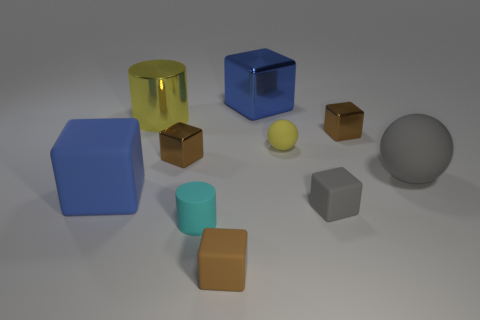Subtract all brown cubes. How many were subtracted if there are1brown cubes left? 2 Subtract all tiny metallic blocks. How many blocks are left? 4 Subtract 1 spheres. How many spheres are left? 1 Subtract all yellow balls. How many balls are left? 1 Subtract all purple cylinders. How many brown blocks are left? 3 Subtract all cylinders. How many objects are left? 8 Add 6 large blue cubes. How many large blue cubes are left? 8 Add 5 tiny brown shiny objects. How many tiny brown shiny objects exist? 7 Subtract 1 gray blocks. How many objects are left? 9 Subtract all blue cylinders. Subtract all cyan spheres. How many cylinders are left? 2 